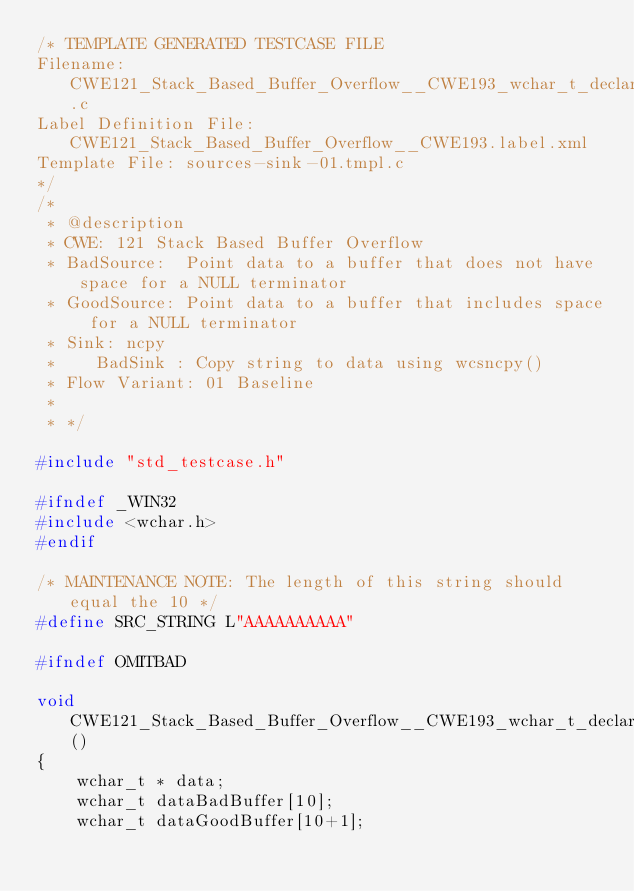<code> <loc_0><loc_0><loc_500><loc_500><_C_>/* TEMPLATE GENERATED TESTCASE FILE
Filename: CWE121_Stack_Based_Buffer_Overflow__CWE193_wchar_t_declare_ncpy_01.c
Label Definition File: CWE121_Stack_Based_Buffer_Overflow__CWE193.label.xml
Template File: sources-sink-01.tmpl.c
*/
/*
 * @description
 * CWE: 121 Stack Based Buffer Overflow
 * BadSource:  Point data to a buffer that does not have space for a NULL terminator
 * GoodSource: Point data to a buffer that includes space for a NULL terminator
 * Sink: ncpy
 *    BadSink : Copy string to data using wcsncpy()
 * Flow Variant: 01 Baseline
 *
 * */

#include "std_testcase.h"

#ifndef _WIN32
#include <wchar.h>
#endif

/* MAINTENANCE NOTE: The length of this string should equal the 10 */
#define SRC_STRING L"AAAAAAAAAA"

#ifndef OMITBAD

void CWE121_Stack_Based_Buffer_Overflow__CWE193_wchar_t_declare_ncpy_01_bad()
{
    wchar_t * data;
    wchar_t dataBadBuffer[10];
    wchar_t dataGoodBuffer[10+1];</code> 